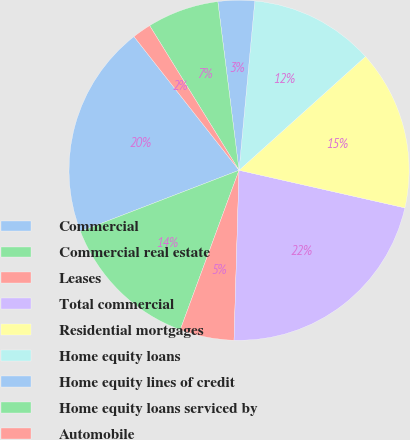Convert chart. <chart><loc_0><loc_0><loc_500><loc_500><pie_chart><fcel>Commercial<fcel>Commercial real estate<fcel>Leases<fcel>Total commercial<fcel>Residential mortgages<fcel>Home equity loans<fcel>Home equity lines of credit<fcel>Home equity loans serviced by<fcel>Automobile<nl><fcel>20.25%<fcel>13.53%<fcel>5.15%<fcel>21.92%<fcel>15.21%<fcel>11.86%<fcel>3.47%<fcel>6.82%<fcel>1.79%<nl></chart> 